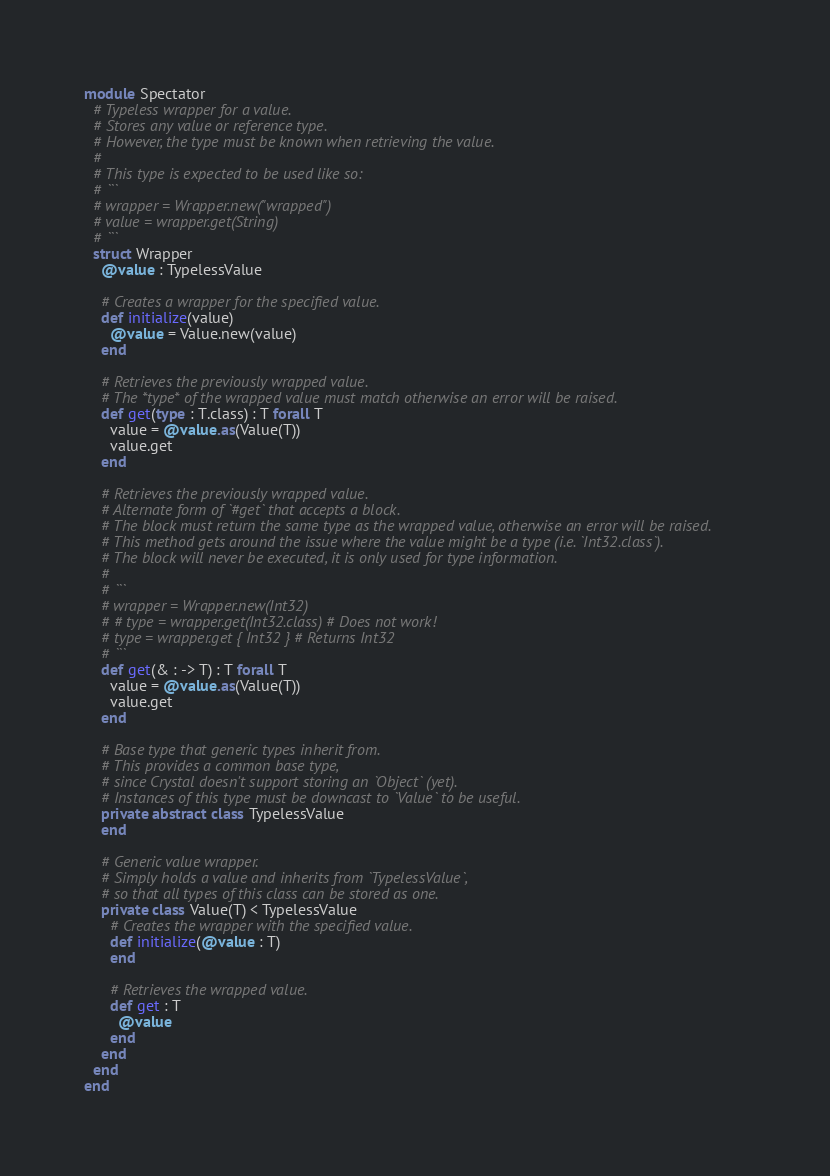<code> <loc_0><loc_0><loc_500><loc_500><_Crystal_>module Spectator
  # Typeless wrapper for a value.
  # Stores any value or reference type.
  # However, the type must be known when retrieving the value.
  #
  # This type is expected to be used like so:
  # ```
  # wrapper = Wrapper.new("wrapped")
  # value = wrapper.get(String)
  # ```
  struct Wrapper
    @value : TypelessValue

    # Creates a wrapper for the specified value.
    def initialize(value)
      @value = Value.new(value)
    end

    # Retrieves the previously wrapped value.
    # The *type* of the wrapped value must match otherwise an error will be raised.
    def get(type : T.class) : T forall T
      value = @value.as(Value(T))
      value.get
    end

    # Retrieves the previously wrapped value.
    # Alternate form of `#get` that accepts a block.
    # The block must return the same type as the wrapped value, otherwise an error will be raised.
    # This method gets around the issue where the value might be a type (i.e. `Int32.class`).
    # The block will never be executed, it is only used for type information.
    #
    # ```
    # wrapper = Wrapper.new(Int32)
    # # type = wrapper.get(Int32.class) # Does not work!
    # type = wrapper.get { Int32 } # Returns Int32
    # ```
    def get(& : -> T) : T forall T
      value = @value.as(Value(T))
      value.get
    end

    # Base type that generic types inherit from.
    # This provides a common base type,
    # since Crystal doesn't support storing an `Object` (yet).
    # Instances of this type must be downcast to `Value` to be useful.
    private abstract class TypelessValue
    end

    # Generic value wrapper.
    # Simply holds a value and inherits from `TypelessValue`,
    # so that all types of this class can be stored as one.
    private class Value(T) < TypelessValue
      # Creates the wrapper with the specified value.
      def initialize(@value : T)
      end

      # Retrieves the wrapped value.
      def get : T
        @value
      end
    end
  end
end
</code> 